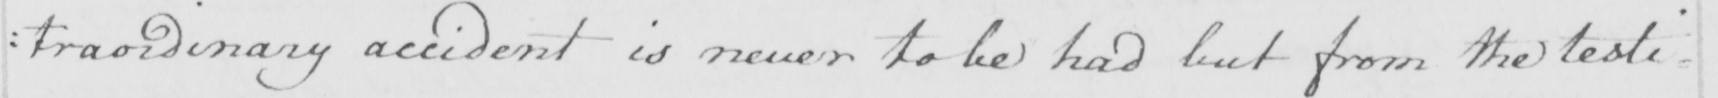Can you tell me what this handwritten text says? : traordinary accident is never to be had but from the testi= 